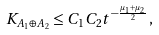<formula> <loc_0><loc_0><loc_500><loc_500>K _ { A _ { 1 } \oplus A _ { 2 } } \leq C _ { 1 } C _ { 2 } t ^ { - \frac { \mu _ { 1 } + \mu _ { 2 } } 2 } ,</formula> 